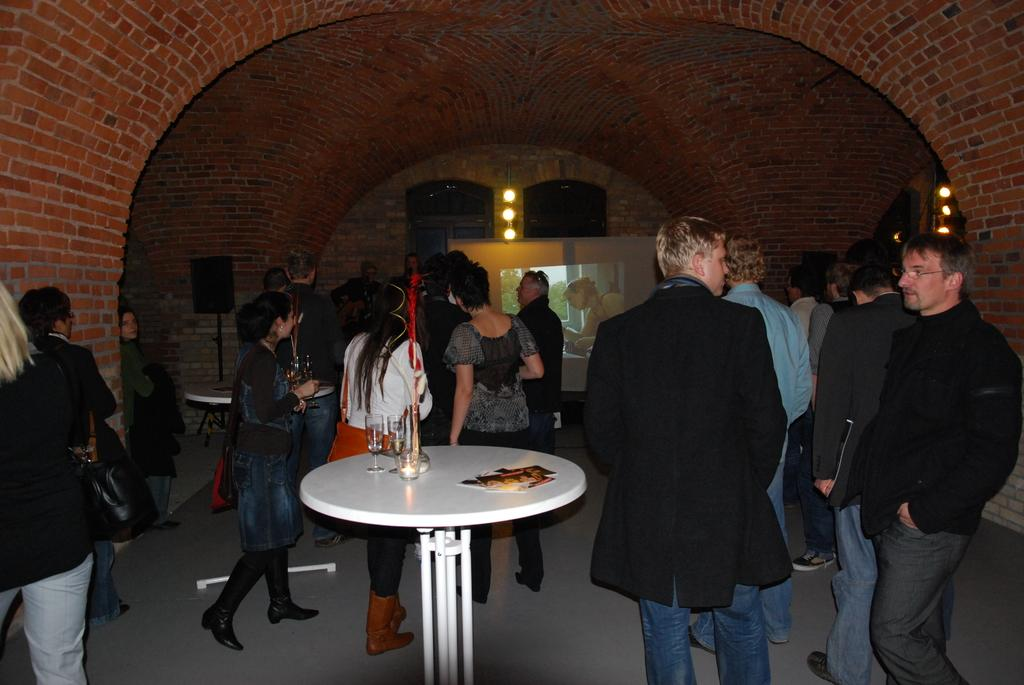How many people are in the image? There is a group of people in the image, but the exact number is not specified. What are the people doing in the image? The people are standing around a white table. What can be seen in the background of the image? There is a projected image in the background. What type of plane is flying over the people in the image? There is no plane visible in the image; the people are standing around a white table with a projected image in the background. 